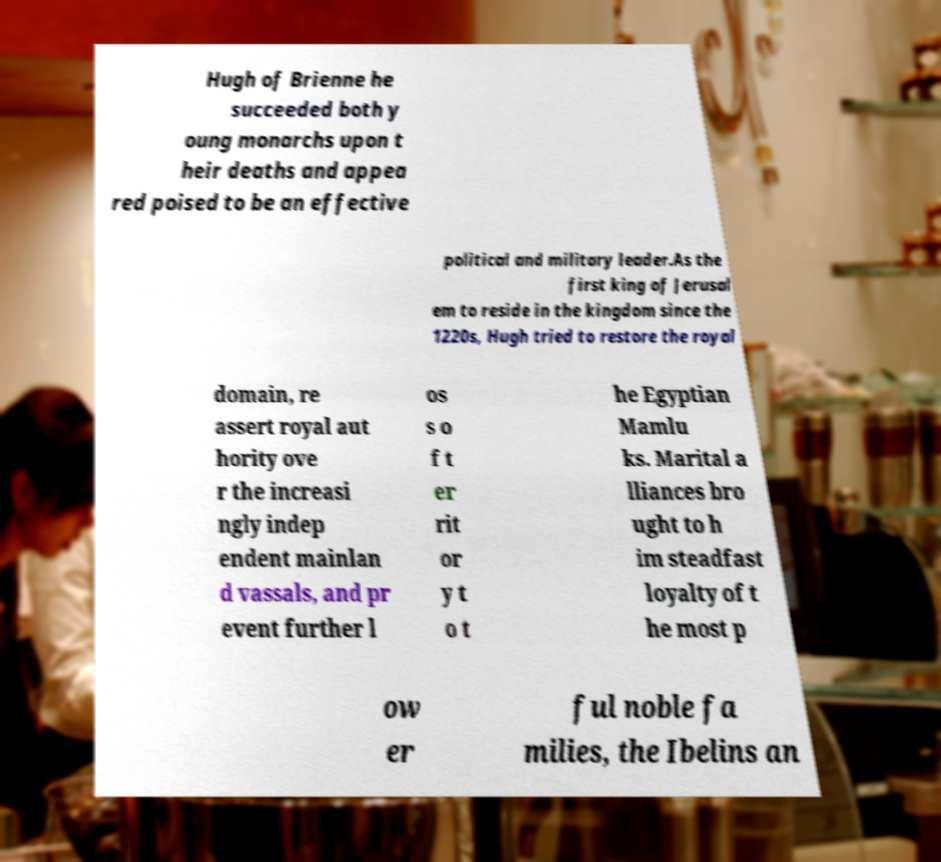Could you extract and type out the text from this image? Hugh of Brienne he succeeded both y oung monarchs upon t heir deaths and appea red poised to be an effective political and military leader.As the first king of Jerusal em to reside in the kingdom since the 1220s, Hugh tried to restore the royal domain, re assert royal aut hority ove r the increasi ngly indep endent mainlan d vassals, and pr event further l os s o f t er rit or y t o t he Egyptian Mamlu ks. Marital a lliances bro ught to h im steadfast loyalty of t he most p ow er ful noble fa milies, the Ibelins an 